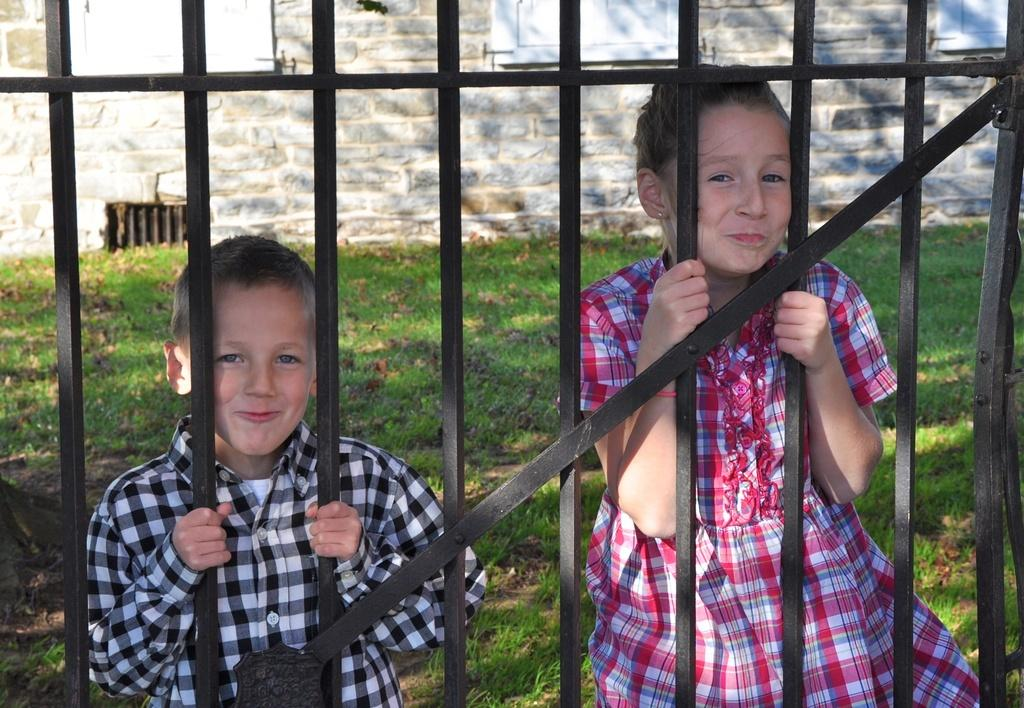How many people are in the image? There are two persons standing in the image. What are the persons holding in their hands? The persons are holding metal rods. What can be seen in the background of the image? There is green grass and a wall made of rocks in the background of the image. Are there any openings in the wall made of rocks? Yes, there are windows in the wall made of rocks. What type of nation is depicted in the image? The image does not depict a nation; it shows two persons holding metal rods, green grass, and a wall made of rocks with windows in the background. 